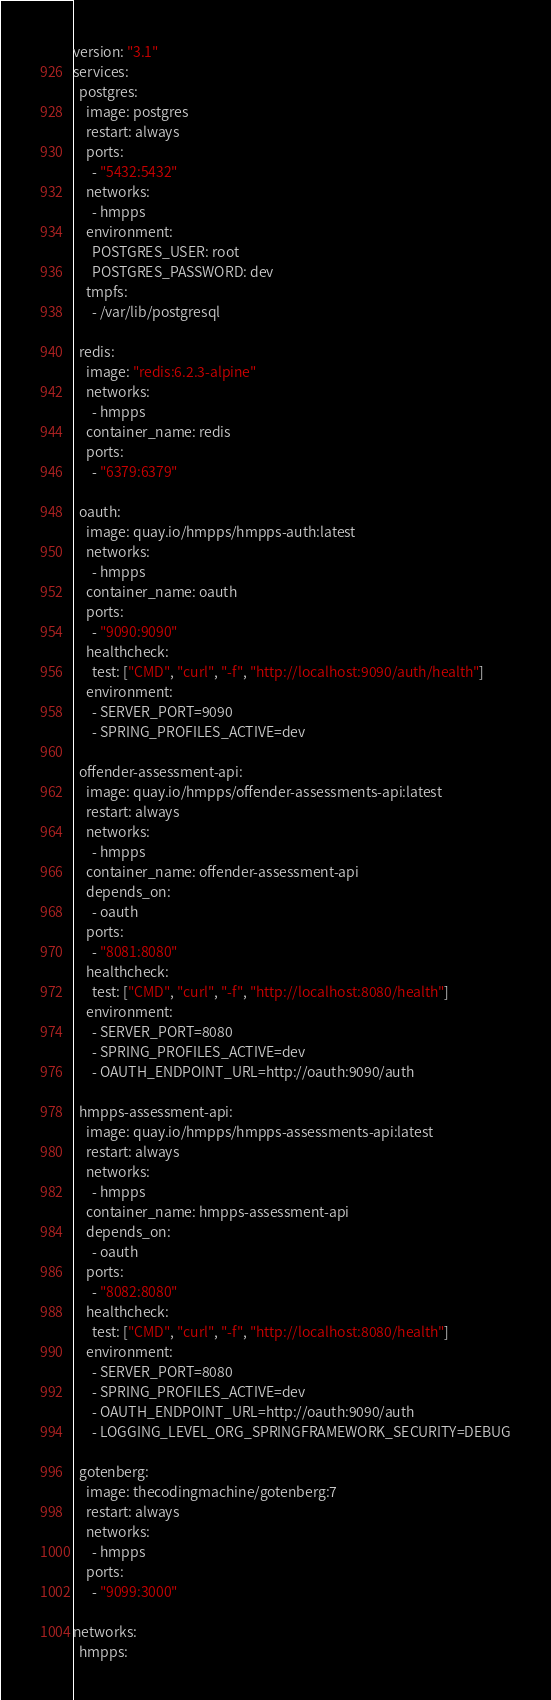Convert code to text. <code><loc_0><loc_0><loc_500><loc_500><_YAML_>version: "3.1"
services:
  postgres:
    image: postgres
    restart: always
    ports:
      - "5432:5432"
    networks:
      - hmpps
    environment:
      POSTGRES_USER: root
      POSTGRES_PASSWORD: dev
    tmpfs:
      - /var/lib/postgresql

  redis:
    image: "redis:6.2.3-alpine"
    networks:
      - hmpps
    container_name: redis
    ports:
      - "6379:6379"

  oauth:
    image: quay.io/hmpps/hmpps-auth:latest
    networks:
      - hmpps
    container_name: oauth
    ports:
      - "9090:9090"
    healthcheck:
      test: ["CMD", "curl", "-f", "http://localhost:9090/auth/health"]
    environment:
      - SERVER_PORT=9090
      - SPRING_PROFILES_ACTIVE=dev

  offender-assessment-api:
    image: quay.io/hmpps/offender-assessments-api:latest
    restart: always
    networks:
      - hmpps
    container_name: offender-assessment-api
    depends_on:
      - oauth
    ports:
      - "8081:8080"
    healthcheck:
      test: ["CMD", "curl", "-f", "http://localhost:8080/health"]
    environment:
      - SERVER_PORT=8080
      - SPRING_PROFILES_ACTIVE=dev
      - OAUTH_ENDPOINT_URL=http://oauth:9090/auth

  hmpps-assessment-api:
    image: quay.io/hmpps/hmpps-assessments-api:latest
    restart: always
    networks:
      - hmpps
    container_name: hmpps-assessment-api
    depends_on:
      - oauth
    ports:
      - "8082:8080"
    healthcheck:
      test: ["CMD", "curl", "-f", "http://localhost:8080/health"]
    environment:
      - SERVER_PORT=8080
      - SPRING_PROFILES_ACTIVE=dev
      - OAUTH_ENDPOINT_URL=http://oauth:9090/auth
      - LOGGING_LEVEL_ORG_SPRINGFRAMEWORK_SECURITY=DEBUG

  gotenberg:
    image: thecodingmachine/gotenberg:7
    restart: always
    networks:
      - hmpps
    ports:
      - "9099:3000"

networks:
  hmpps:
</code> 